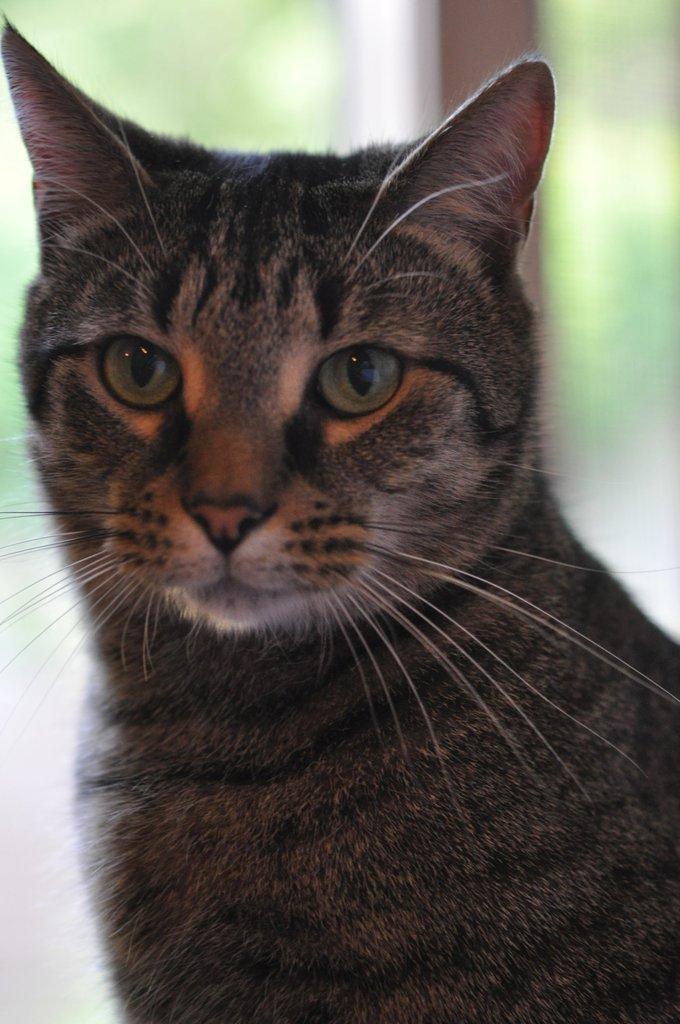How would you summarize this image in a sentence or two? In this image I can see the cat which is in back, grey and brown color. And there is a blurred background. 